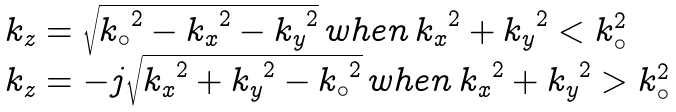Convert formula to latex. <formula><loc_0><loc_0><loc_500><loc_500>\begin{array} { l } k _ { z } = \sqrt { { k _ { \circ } } ^ { 2 } - { k _ { x } } ^ { 2 } - { k _ { y } } ^ { 2 } } \, w h e n \, { k _ { x } } ^ { 2 } + { k _ { y } } ^ { 2 } < k _ { \circ } ^ { 2 } \\ k _ { z } = - j \sqrt { { k _ { x } } ^ { 2 } + { k _ { y } } ^ { 2 } - { k _ { \circ } } ^ { 2 } } \, w h e n \, { k _ { x } } ^ { 2 } + { k _ { y } } ^ { 2 } > k _ { \circ } ^ { 2 } \\ \end{array}</formula> 